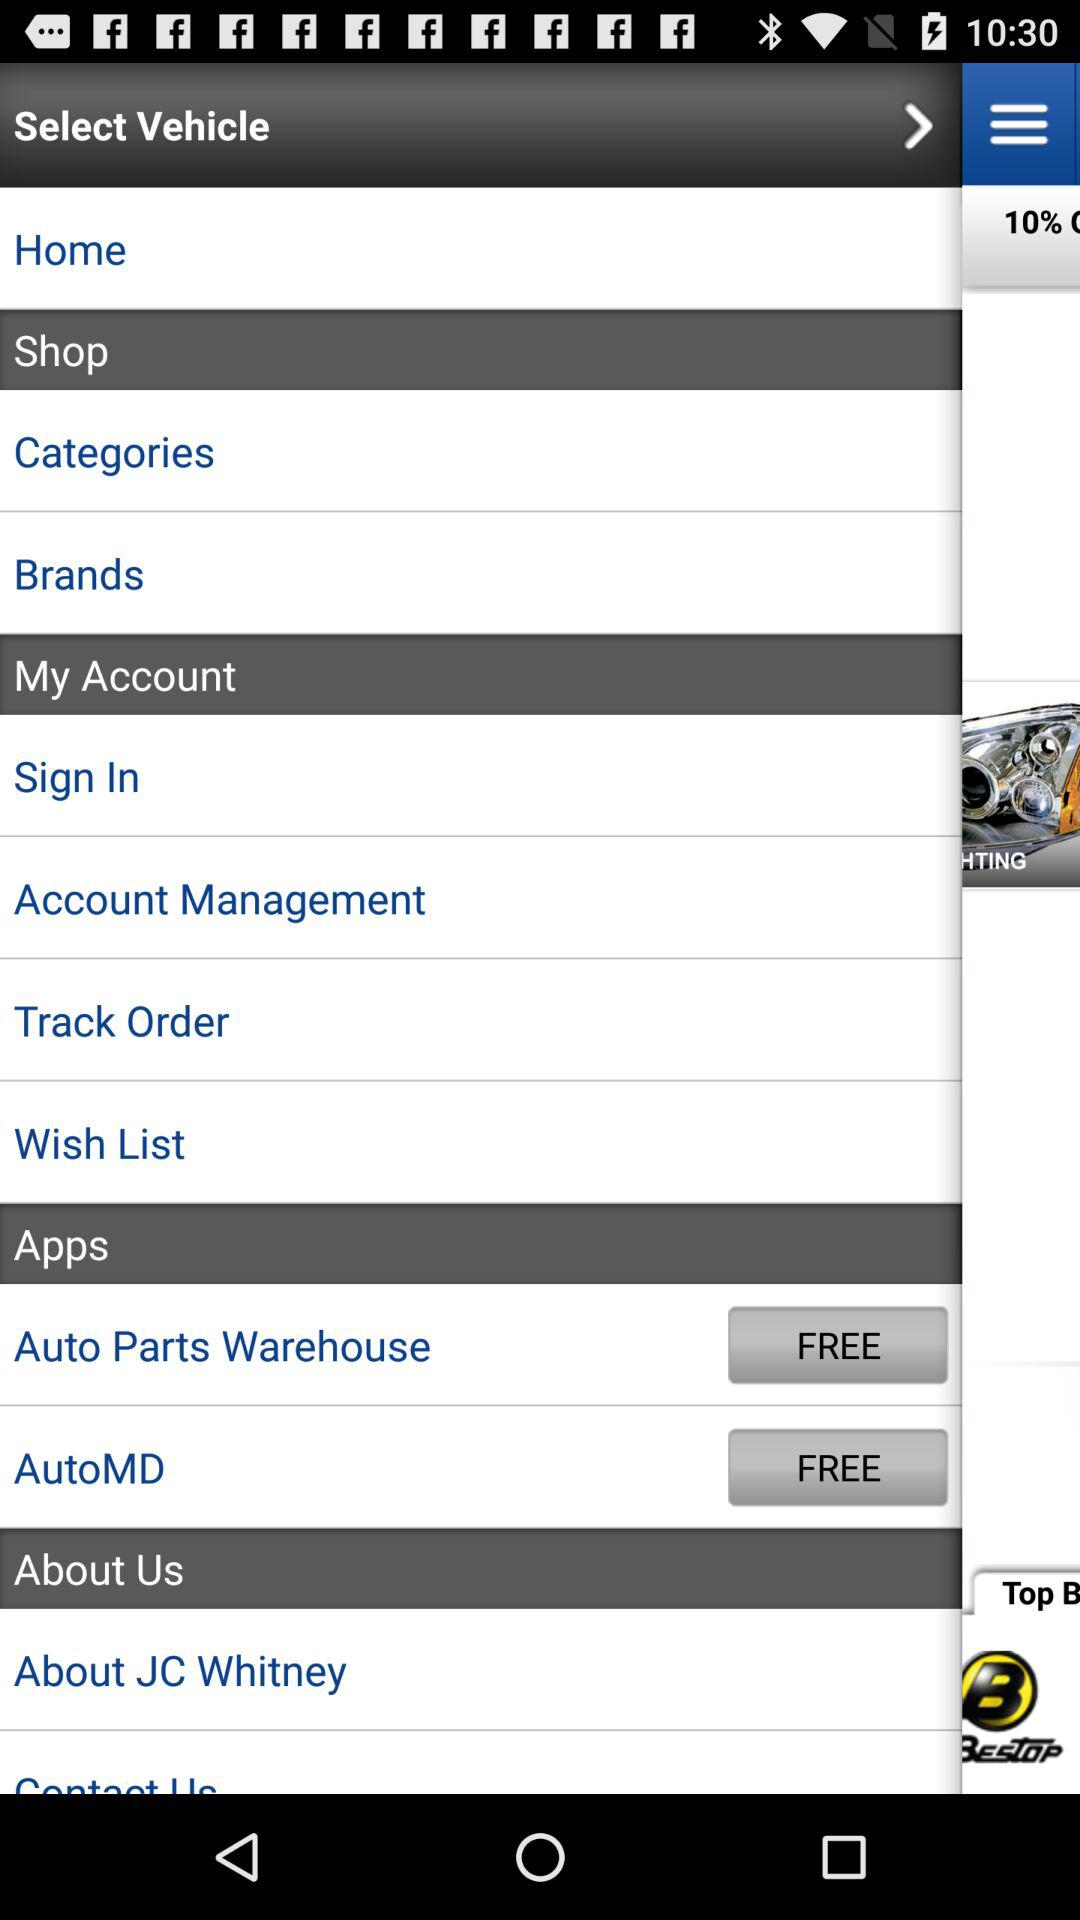What are the names of the free applications? The names of the free applications are "Auto Parts Warehouse" and "AutoMD". 